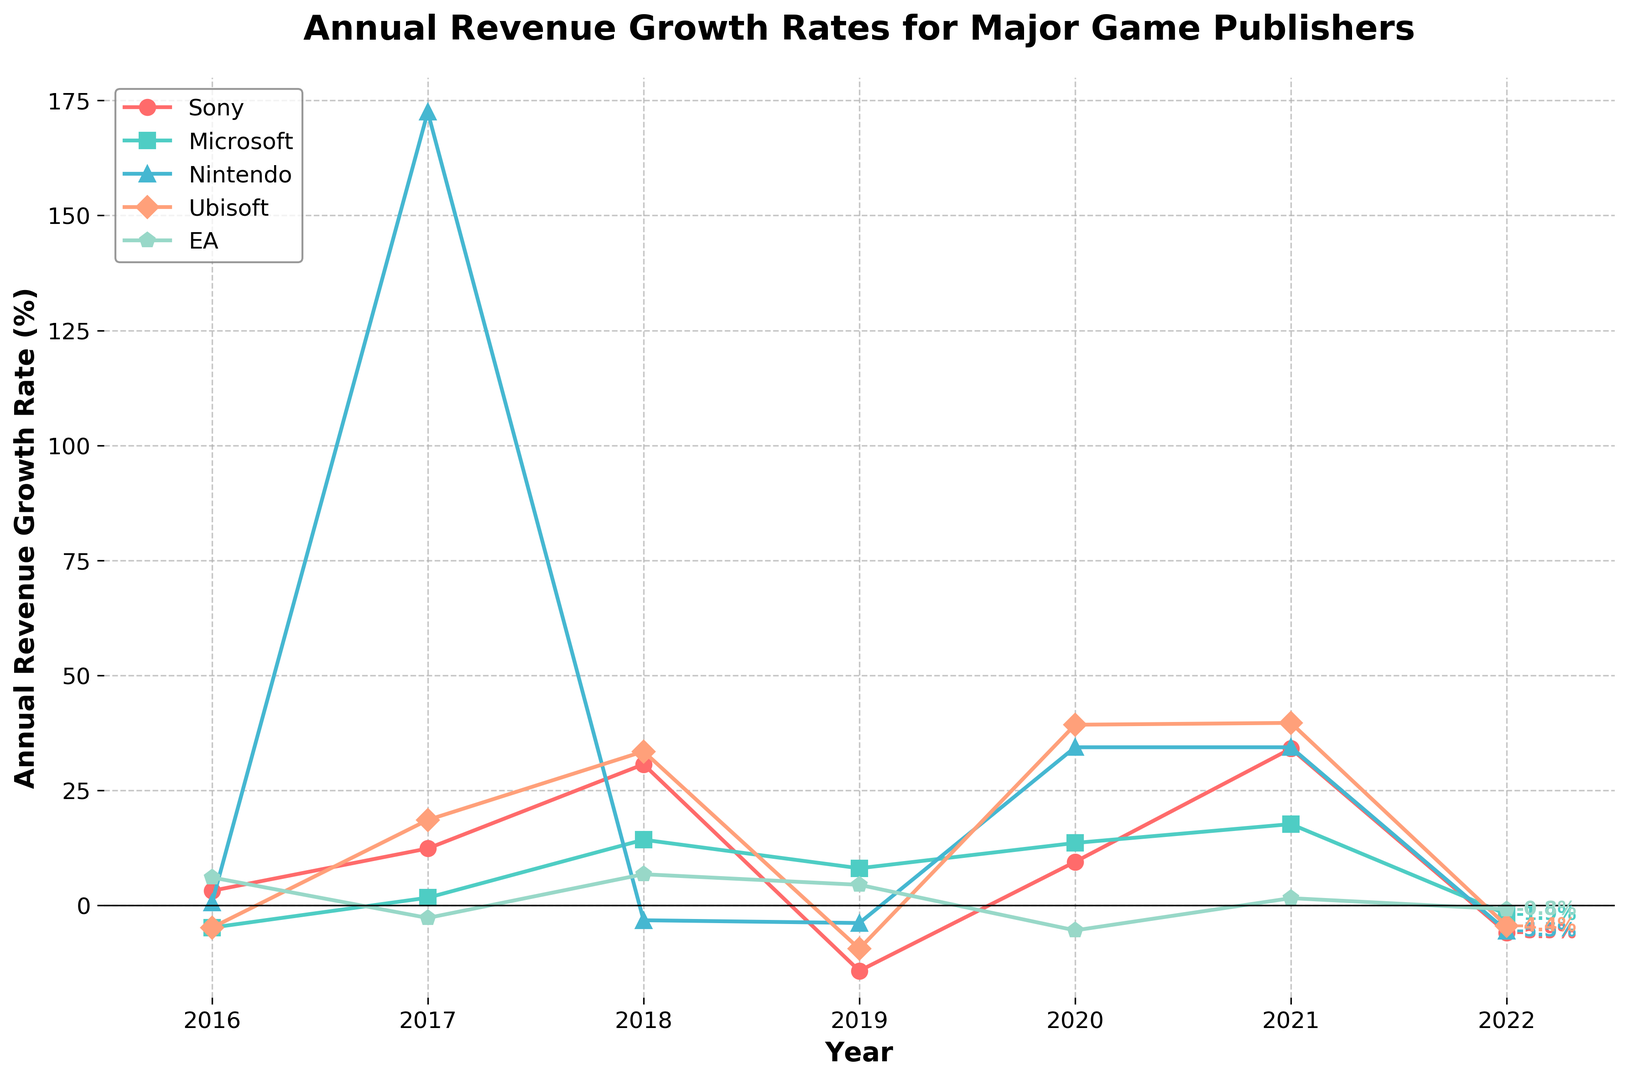What's the overall trend in Sony's annual revenue growth rate from 2016 to 2022? Sony's annual revenue growth rate started at 3.2% in 2016, spiked to 34.1% in 2021, but dropped to -5.9% by 2022. The overall trend is a significant increase followed by a sharp decline.
Answer: Significant increase followed by sharp decline Which year showed the highest growth rate for Ubisoft? In 2021, Ubisoft had the highest growth rate at 39.7%, which is highlighted by the plot as the peak value.
Answer: 2021 Compare the annual revenue growth rates of Nintendo and Microsoft in 2020. Which one was higher? In 2020, Nintendo had a growth rate of 34.4% while Microsoft had 13.6%. Clearly, Nintendo's rate was higher.
Answer: Nintendo Which company had the lowest revenue growth rate in 2016, and what was the value? Ubisoft and Microsoft both had the lowest revenue growth rate in 2016, at -4.8%.
Answer: Ubisoft and Microsoft, -4.8% What was the average annual revenue growth rate for EA from 2016 to 2022? Sum of EA's growth rates: 6.1% + (-2.7%) + 6.8% + 4.5% + (-5.4%) + 1.6% + (-0.8%) = 10.1%. There are 7 years, so the average growth rate is 10.1% / 7 ≈ 1.44%.
Answer: 1.44% In which years did Sony experience a negative revenue growth rate? Sony had negative growth rates in 2019 (-14.2%) and 2022 (-5.9%).
Answer: 2019 and 2022 Compare the revenue growth of Ubisoft in 2018 and 2019. By how much did it change? Ubisoft's growth rate in 2018 was 33.5% and in 2019 it was -9.4%. The change is 33.5% - (-9.4%) = 42.9%.
Answer: 42.9% What was the trend for Nintendo's revenue growth rate in 2017 and 2018, and how significant was the change? In 2017, Nintendo had a growth rate of 172.5%, but it declined to -3.2% in 2018, making the change 172.5% - (-3.2%) = 175.7%, which is significant.
Answer: Significant decline, 175.7% Visually, which company's line is represented by the color red? Sony's annual revenue growth rate line is represented by the color red, as indicated in the legend.
Answer: Sony What was Microsoft's highest annual revenue growth rate from 2016 to 2022 and in which year did it occur? Microsoft's highest annual revenue growth rate was 17.7% in 2021.
Answer: 17.7% in 2021 